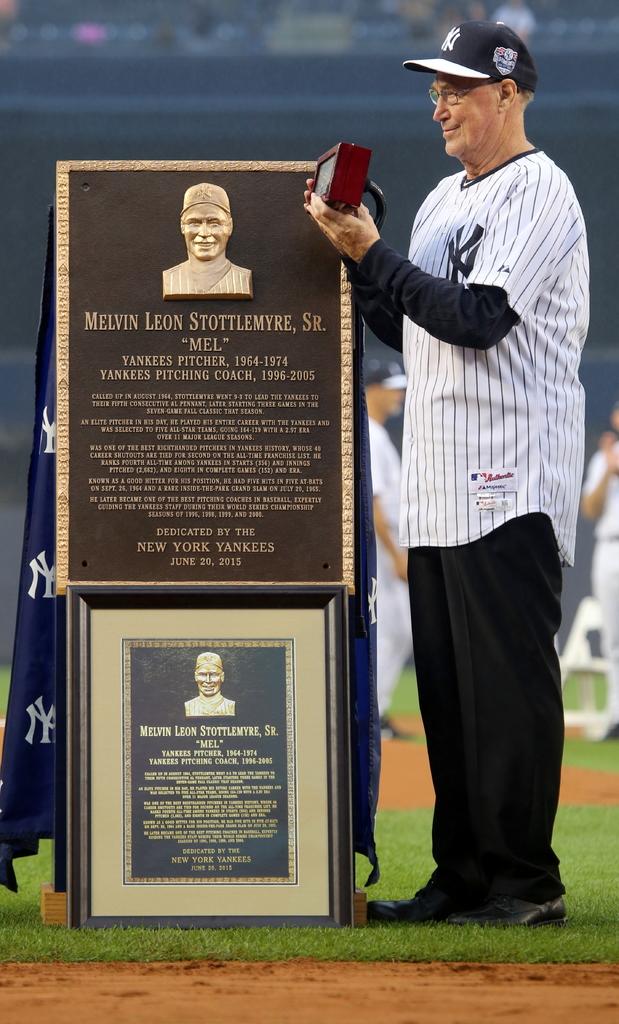Who are they honoring?
Your answer should be compact. Melvin leon stottlemyre, sr. What letters are on the man's jersey?
Your answer should be compact. Ny. 